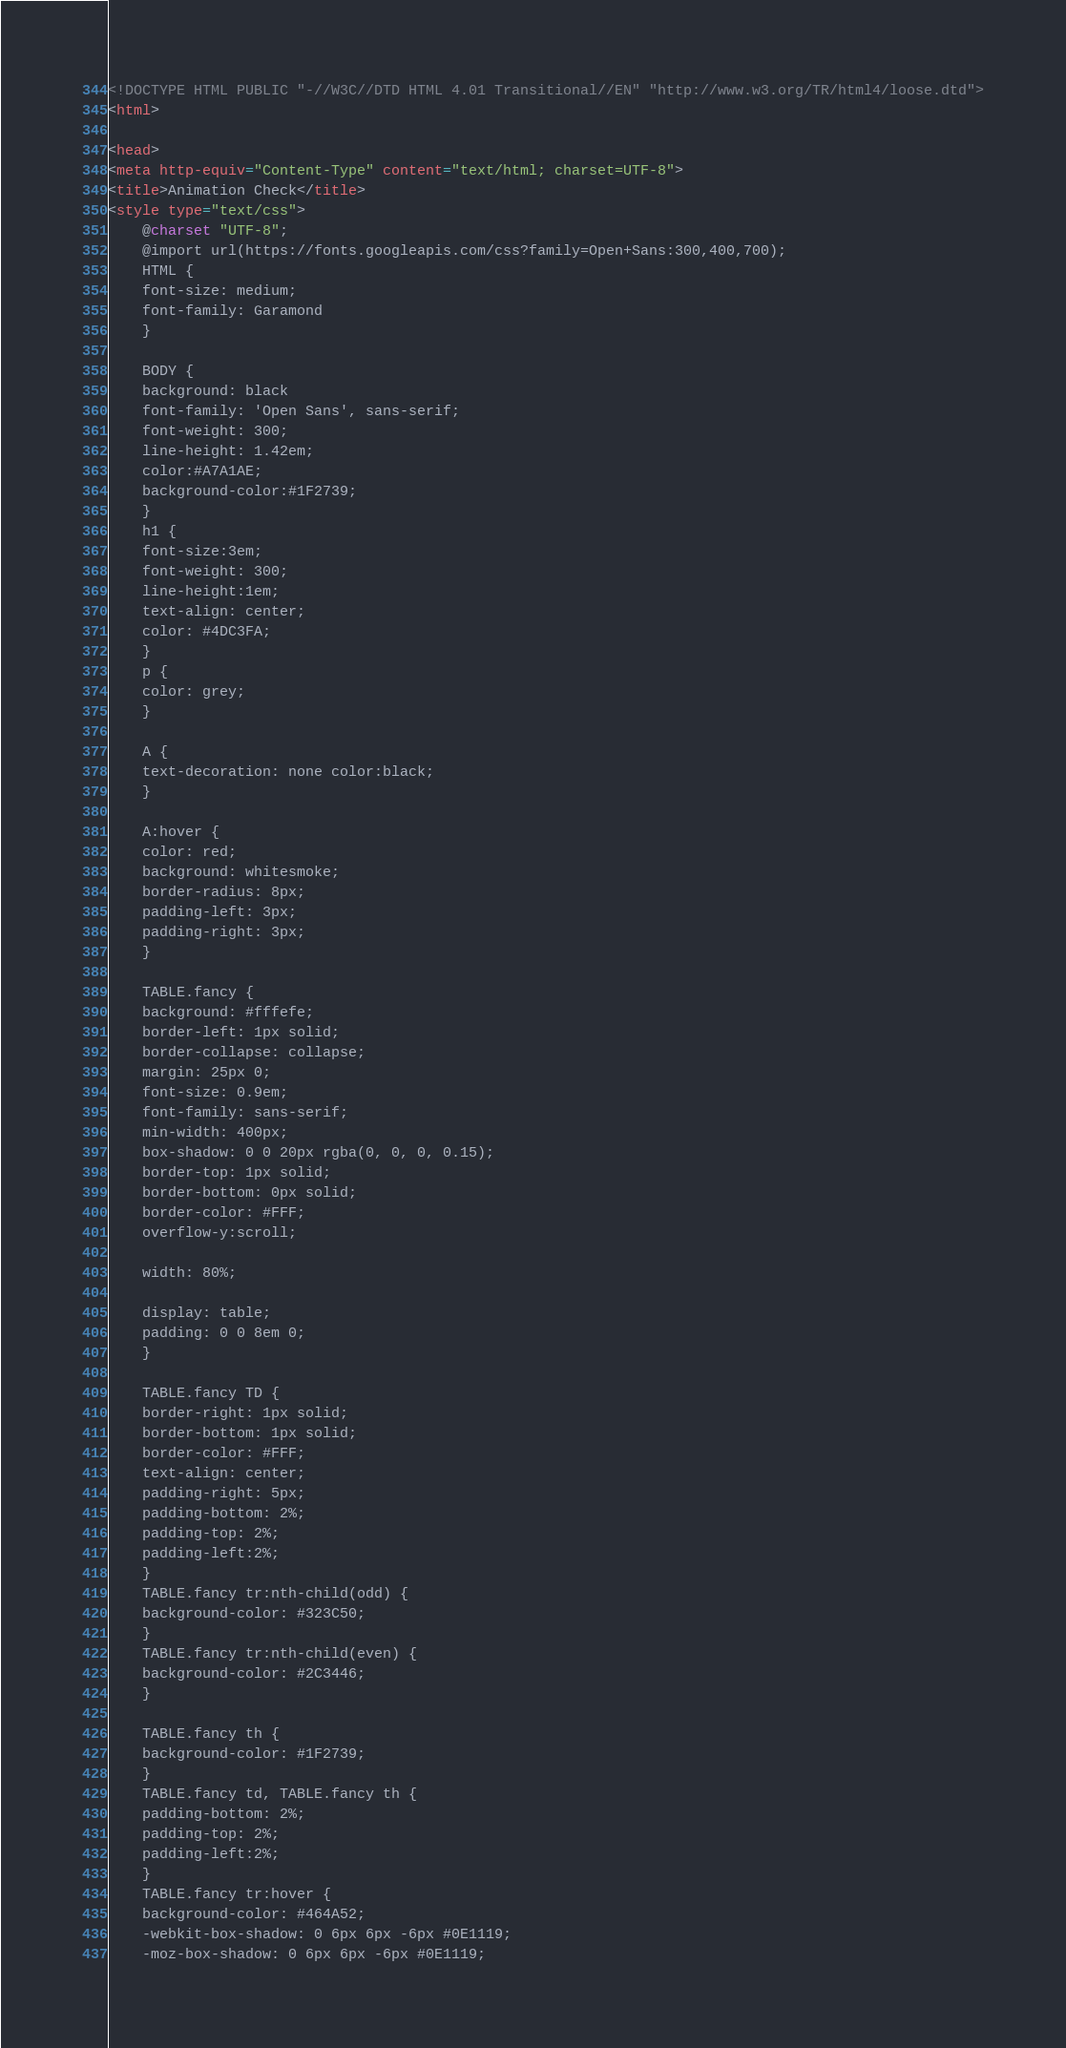Convert code to text. <code><loc_0><loc_0><loc_500><loc_500><_HTML_><!DOCTYPE HTML PUBLIC "-//W3C//DTD HTML 4.01 Transitional//EN" "http://www.w3.org/TR/html4/loose.dtd">
<html>

<head>
<meta http-equiv="Content-Type" content="text/html; charset=UTF-8">
<title>Animation Check</title>
<style type="text/css">
    @charset "UTF-8";
    @import url(https://fonts.googleapis.com/css?family=Open+Sans:300,400,700);
    HTML {
    font-size: medium;
    font-family: Garamond
    }

    BODY {
    background: black
    font-family: 'Open Sans', sans-serif;
    font-weight: 300;
    line-height: 1.42em;
    color:#A7A1AE;
    background-color:#1F2739;
    }
    h1 {
    font-size:3em;
    font-weight: 300;
    line-height:1em;
    text-align: center;
    color: #4DC3FA;
    }
    p {
    color: grey;
    }

    A {
    text-decoration: none color:black;
    }

    A:hover {
    color: red;
    background: whitesmoke;
    border-radius: 8px;
    padding-left: 3px;
    padding-right: 3px;
    }

    TABLE.fancy {
    background: #fffefe;
    border-left: 1px solid;
    border-collapse: collapse;
    margin: 25px 0;
    font-size: 0.9em;
    font-family: sans-serif;
    min-width: 400px;
    box-shadow: 0 0 20px rgba(0, 0, 0, 0.15);
    border-top: 1px solid;
    border-bottom: 0px solid;
    border-color: #FFF;
    overflow-y:scroll;

    width: 80%;

    display: table;
    padding: 0 0 8em 0;
    }

    TABLE.fancy TD {
    border-right: 1px solid;
    border-bottom: 1px solid;
    border-color: #FFF;
    text-align: center;
    padding-right: 5px;
    padding-bottom: 2%;
    padding-top: 2%;
    padding-left:2%;
    }
    TABLE.fancy tr:nth-child(odd) {
    background-color: #323C50;
    }
    TABLE.fancy tr:nth-child(even) {
    background-color: #2C3446;
    }

    TABLE.fancy th {
    background-color: #1F2739;
    }
    TABLE.fancy td, TABLE.fancy th {
    padding-bottom: 2%;
    padding-top: 2%;
    padding-left:2%;
    }
    TABLE.fancy tr:hover {
    background-color: #464A52;
    -webkit-box-shadow: 0 6px 6px -6px #0E1119;
    -moz-box-shadow: 0 6px 6px -6px #0E1119;</code> 